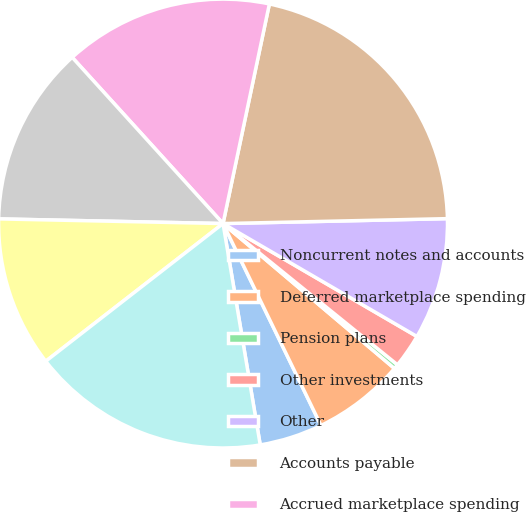Convert chart. <chart><loc_0><loc_0><loc_500><loc_500><pie_chart><fcel>Noncurrent notes and accounts<fcel>Deferred marketplace spending<fcel>Pension plans<fcel>Other investments<fcel>Other<fcel>Accounts payable<fcel>Accrued marketplace spending<fcel>Accrued compensation and<fcel>Dividends payable<fcel>Other current liabilities<nl><fcel>4.54%<fcel>6.64%<fcel>0.34%<fcel>2.44%<fcel>8.74%<fcel>21.34%<fcel>15.04%<fcel>12.94%<fcel>10.84%<fcel>17.14%<nl></chart> 